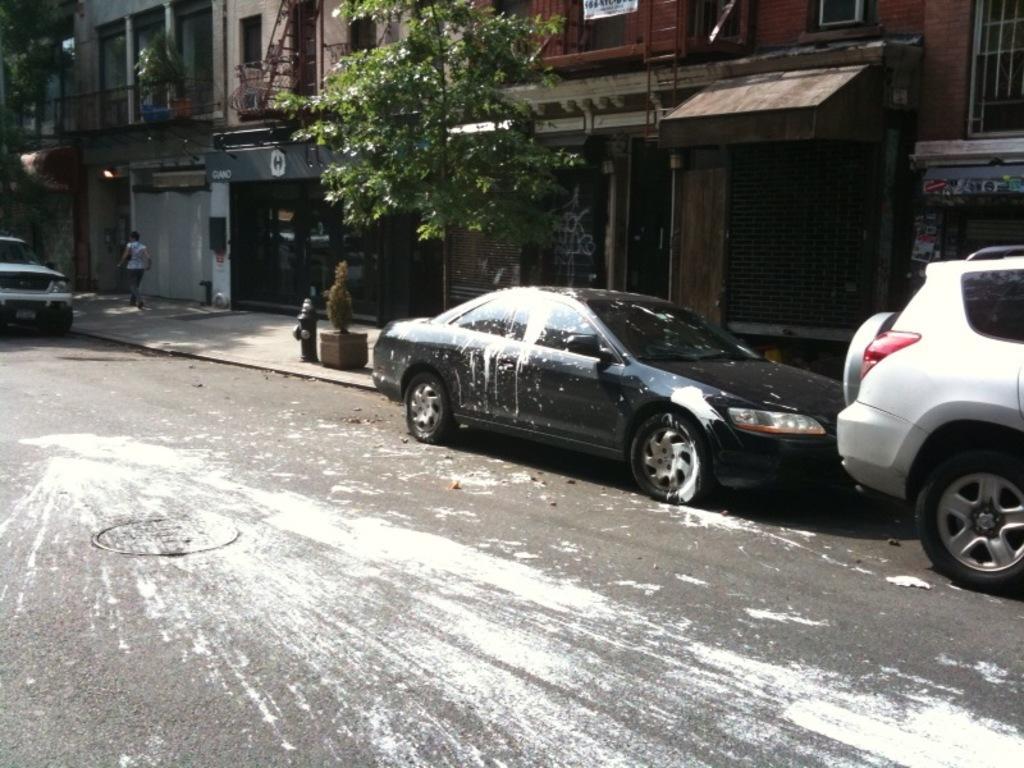Please provide a concise description of this image. In this image we can see some buildings with windows, ladders and the railing. We can also see some trees, a plant in a pot, a person walking on the footpath and some cars on the road. We can also see some white color on the road and a car. 